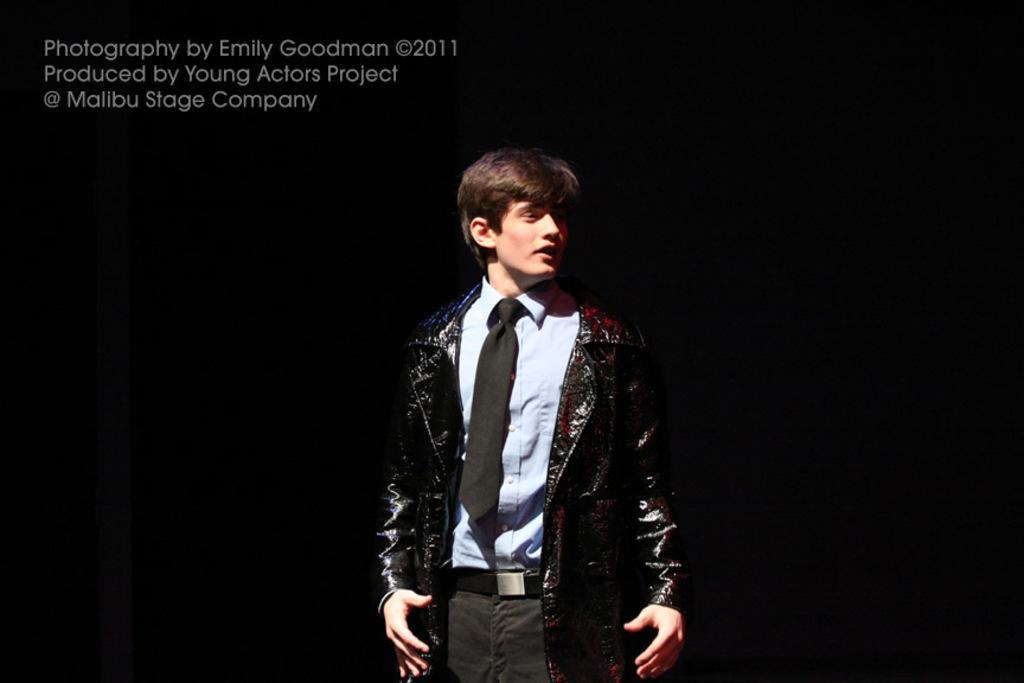Can you describe this image briefly? In the center of this picture we can see a person wearing blue color shirt, tie, jacket and seems to be standing. The background of the image is very dark. In the top left corner we can see the text and numbers on the image. 